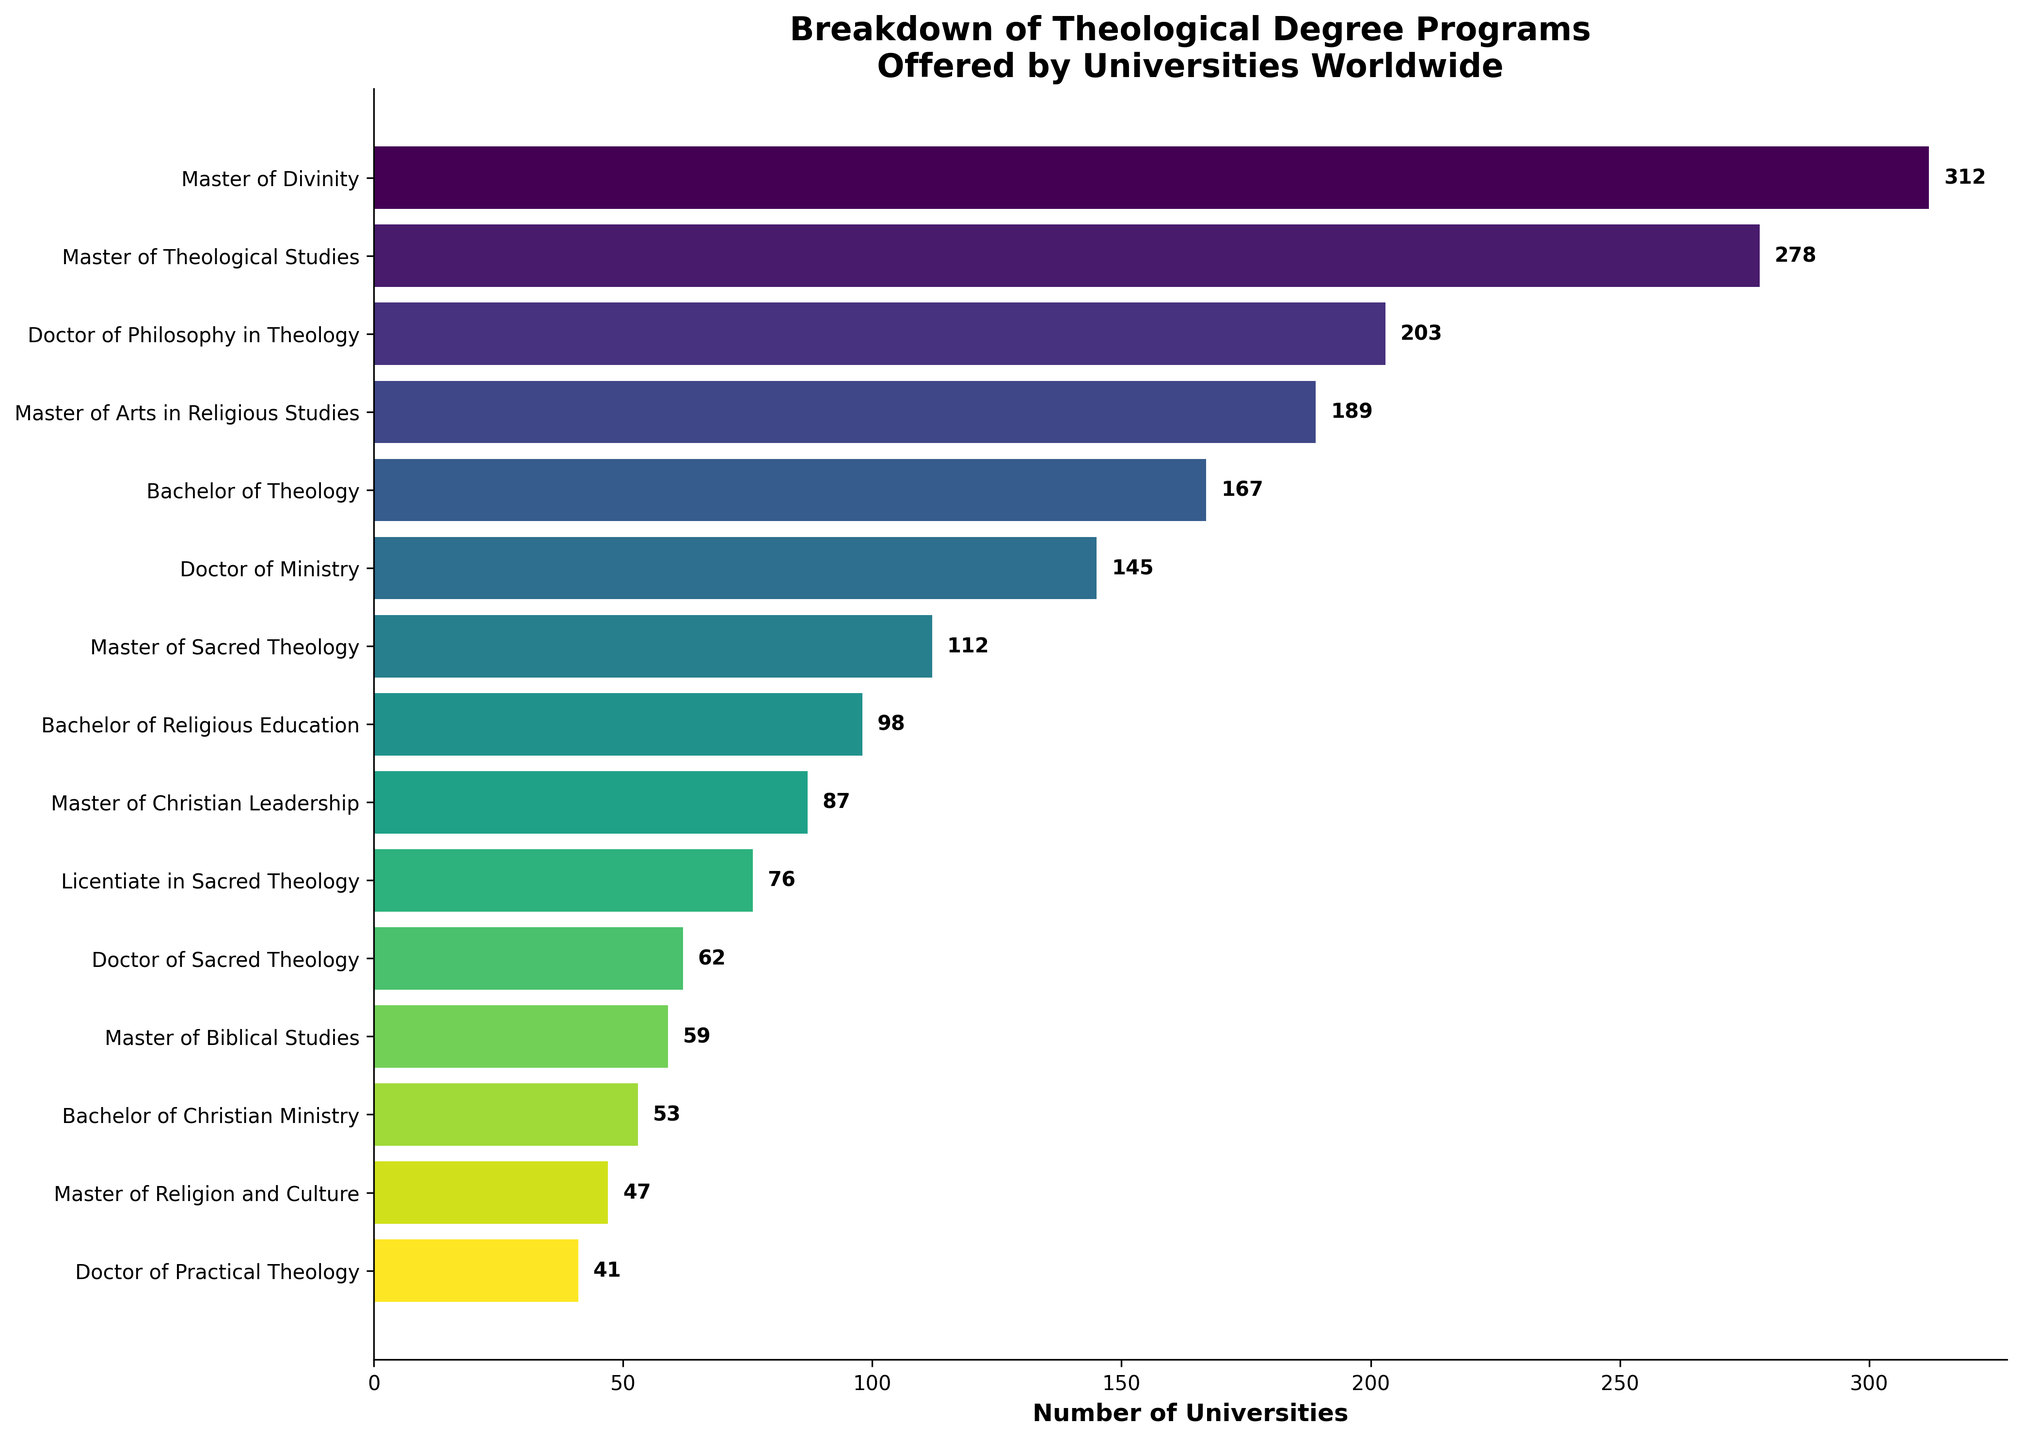What is the most offered theological degree program worldwide? The bar chart shows different theological degree programs offered by universities worldwide. The bar that extends the furthest to the right represents the most offered degree program. In this case, the "Master of Divinity" has the longest bar.
Answer: Master of Divinity Which program is offered by fewer universities: Bachelor of Theology or Doctor of Ministry? Looking at the lengths of the bars and the numerical values associated with each, "Bachelor of Theology" has a value of 167, while "Doctor of Ministry" has a value of 145. Therefore, "Doctor of Ministry" is offered by fewer universities.
Answer: Doctor of Ministry What is the total number of universities offering Master of Biblical Studies and Master of Christian Leadership programs combined? According to the chart, "Master of Biblical Studies" is offered by 59 universities, and "Master of Christian Leadership" is offered by 87 universities. Adding these values gives a total of 59 + 87 = 146.
Answer: 146 How many more universities offer a Master of Theological Studies than offer a Doctor of Sacred Theology? The bar chart shows that the "Master of Theological Studies" program is offered by 278 universities, whereas the "Doctor of Sacred Theology" is offered by 62 universities. The difference is 278 - 62 = 216.
Answer: 216 Rank the top three most offered programs. The chart's bars indicate the number of universities offering each program. The top three programs are identified by the longest bars: (1) Master of Divinity (312), (2) Master of Theological Studies (278), (3) Doctor of Philosophy in Theology (203).
Answer: Master of Divinity, Master of Theological Studies, Doctor of Philosophy in Theology What fraction of the total programs does the Master of Divinity represent? First, find the total number of programs offered by universities: 312 + 278 + 203 + ... + 41 = 1729. The Master of Divinity is offered by 312 universities. The fraction is 312/1729.
Answer: 312/1729 Which degree programs are offered by fewer than 100 universities? By observing the lengths and values of the bars, the programs offered by fewer than 100 universities are: Bachelor of Religious Education (98), Master of Christian Leadership (87), Licentiate in Sacred Theology (76), Doctor of Sacred Theology (62), Master of Biblical Studies (59), Bachelor of Christian Ministry (53), Master of Religion and Culture (47), Doctor of Practical Theology (41).
Answer: Bachelor of Religious Education, Master of Christian Leadership, Licentiate in Sacred Theology, Doctor of Sacred Theology, Master of Biblical Studies, Bachelor of Christian Ministry, Master of Religion and Culture, Doctor of Practical Theology Is the number of universities offering Bachelor of Theology more than double the number offering Doctor of Practical Theology? Bachelor of Theology is offered by 167 universities, and Doctor of Practical Theology by 41 universities. Doubling the latter gives 41 * 2 = 82. Since 167 > 82, the number offering Bachelor of Theology is more than double those offering Doctor of Practical Theology.
Answer: Yes What is the average number of universities offering the top 5 most popular programs? The top 5 programs by the number of universities are: Master of Divinity (312), Master of Theological Studies (278), Doctor of Philosophy in Theology (203), Master of Arts in Religious Studies (189), and Bachelor of Theology (167). The average is (312 + 278 + 203 + 189 + 167) / 5 = 229.8.
Answer: 229.8 